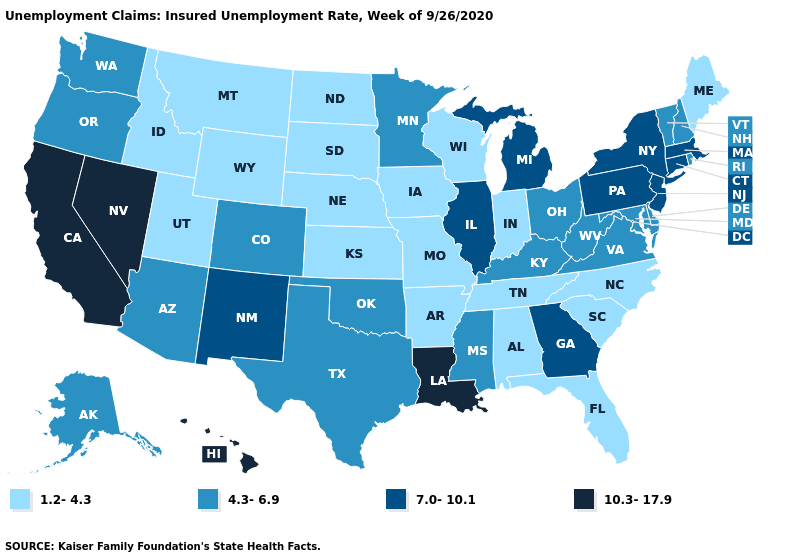Name the states that have a value in the range 7.0-10.1?
Be succinct. Connecticut, Georgia, Illinois, Massachusetts, Michigan, New Jersey, New Mexico, New York, Pennsylvania. Does Illinois have the highest value in the MidWest?
Short answer required. Yes. What is the highest value in the Northeast ?
Be succinct. 7.0-10.1. Name the states that have a value in the range 7.0-10.1?
Be succinct. Connecticut, Georgia, Illinois, Massachusetts, Michigan, New Jersey, New Mexico, New York, Pennsylvania. What is the value of Oklahoma?
Answer briefly. 4.3-6.9. What is the value of West Virginia?
Answer briefly. 4.3-6.9. What is the highest value in states that border California?
Write a very short answer. 10.3-17.9. Which states have the highest value in the USA?
Be succinct. California, Hawaii, Louisiana, Nevada. What is the lowest value in the Northeast?
Concise answer only. 1.2-4.3. What is the value of South Carolina?
Write a very short answer. 1.2-4.3. Among the states that border New Jersey , does New York have the lowest value?
Keep it brief. No. Name the states that have a value in the range 10.3-17.9?
Concise answer only. California, Hawaii, Louisiana, Nevada. Among the states that border Florida , which have the highest value?
Answer briefly. Georgia. Does Illinois have the highest value in the MidWest?
Concise answer only. Yes. Does California have the highest value in the West?
Quick response, please. Yes. 